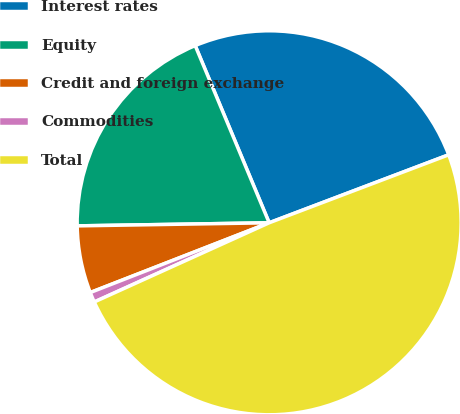Convert chart. <chart><loc_0><loc_0><loc_500><loc_500><pie_chart><fcel>Interest rates<fcel>Equity<fcel>Credit and foreign exchange<fcel>Commodities<fcel>Total<nl><fcel>25.53%<fcel>18.96%<fcel>5.66%<fcel>0.85%<fcel>48.99%<nl></chart> 